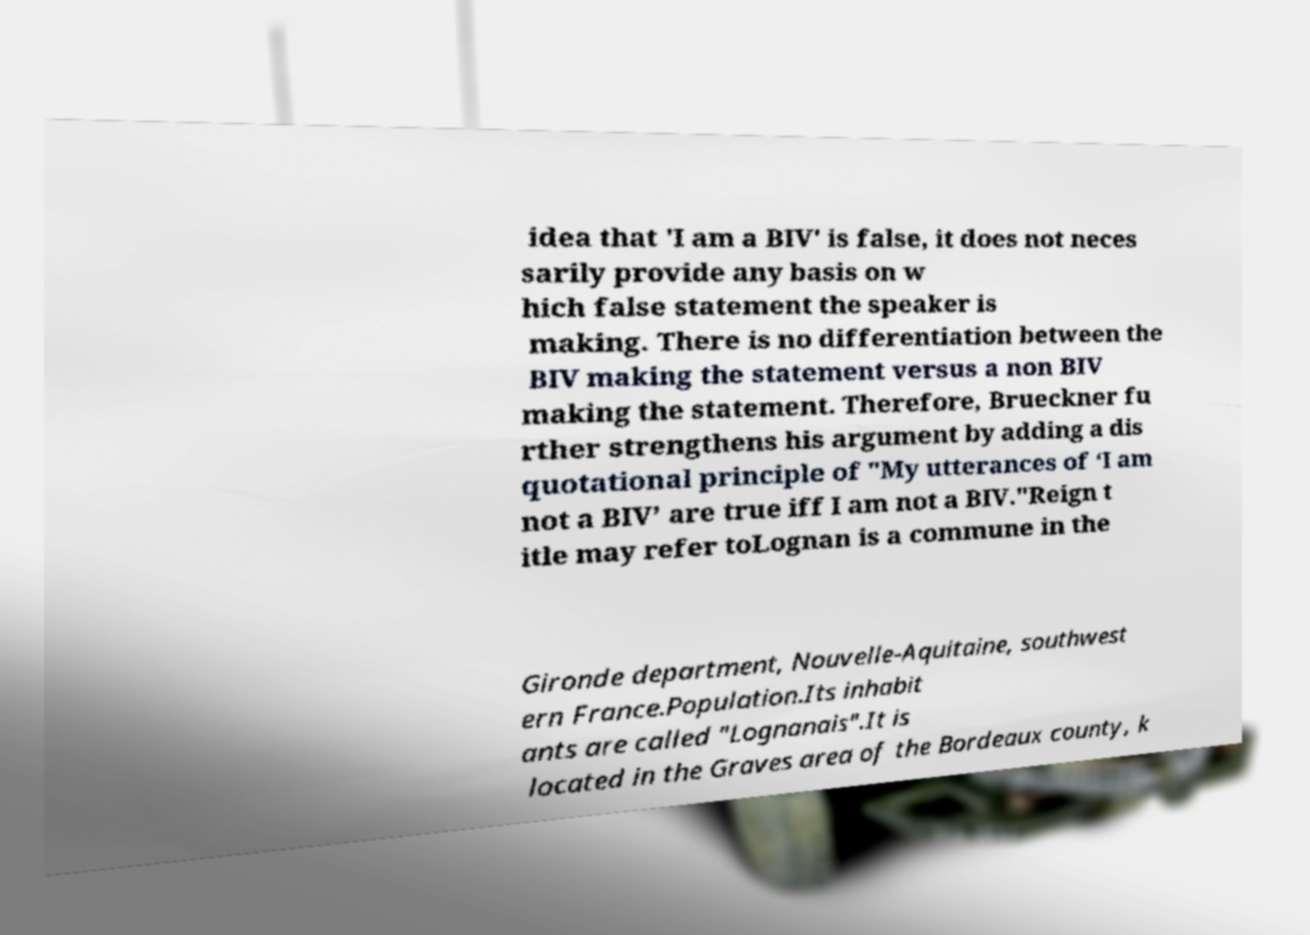Can you read and provide the text displayed in the image?This photo seems to have some interesting text. Can you extract and type it out for me? idea that 'I am a BIV' is false, it does not neces sarily provide any basis on w hich false statement the speaker is making. There is no differentiation between the BIV making the statement versus a non BIV making the statement. Therefore, Brueckner fu rther strengthens his argument by adding a dis quotational principle of "My utterances of ‘I am not a BIV’ are true iff I am not a BIV."Reign t itle may refer toLognan is a commune in the Gironde department, Nouvelle-Aquitaine, southwest ern France.Population.Its inhabit ants are called "Lognanais".It is located in the Graves area of the Bordeaux county, k 